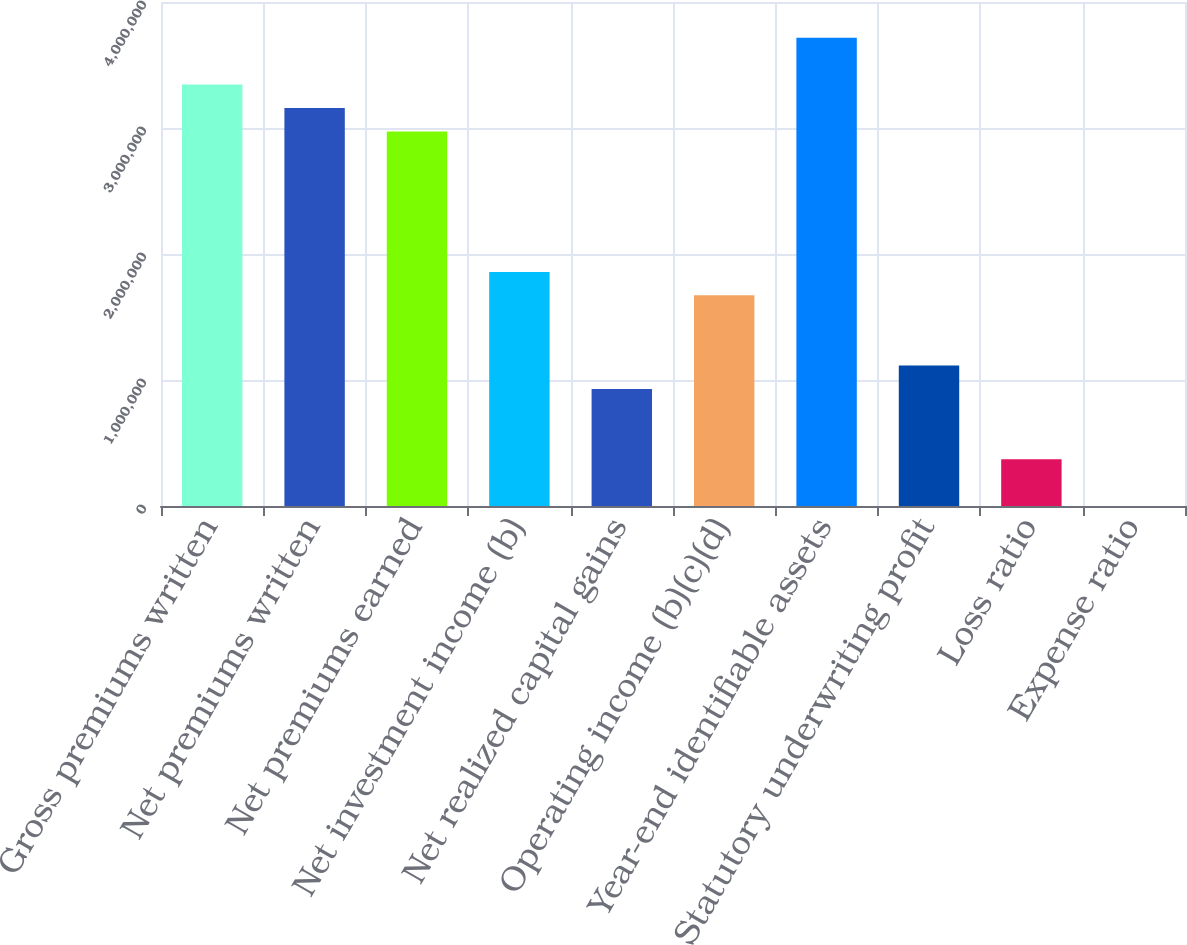Convert chart. <chart><loc_0><loc_0><loc_500><loc_500><bar_chart><fcel>Gross premiums written<fcel>Net premiums written<fcel>Net premiums earned<fcel>Net investment income (b)<fcel>Net realized capital gains<fcel>Operating income (b)(c)(d)<fcel>Year-end identifiable assets<fcel>Statutory underwriting profit<fcel>Loss ratio<fcel>Expense ratio<nl><fcel>3.34455e+06<fcel>3.15874e+06<fcel>2.97294e+06<fcel>1.85809e+06<fcel>929058<fcel>1.67229e+06<fcel>3.71617e+06<fcel>1.11486e+06<fcel>371636<fcel>21.5<nl></chart> 